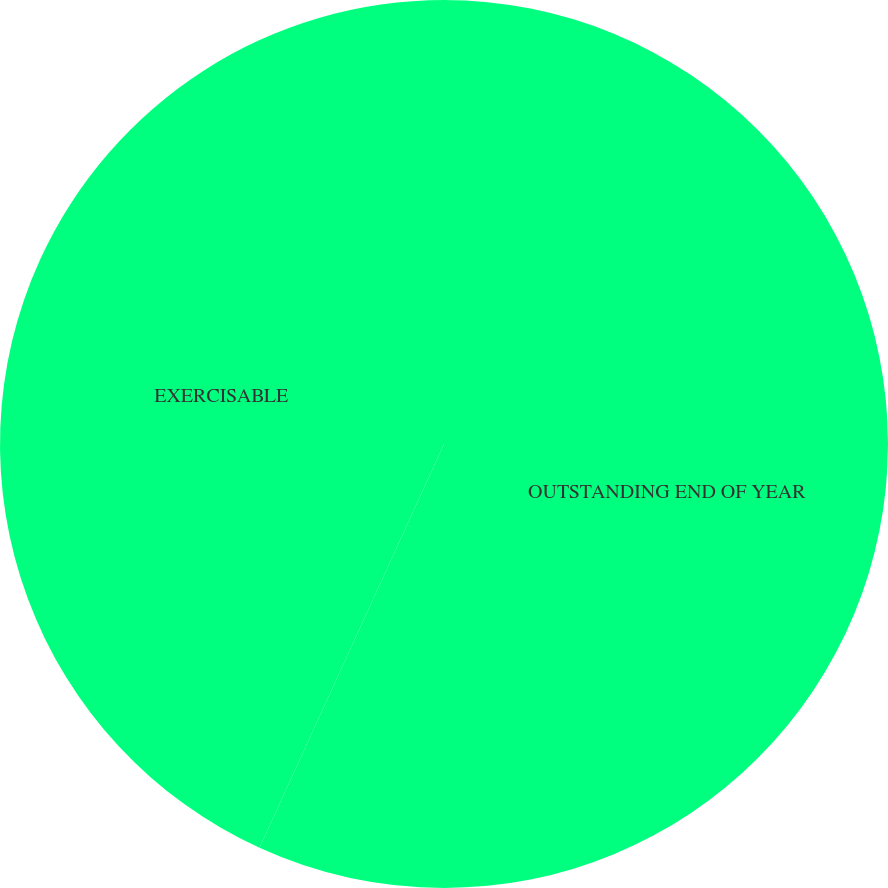Convert chart to OTSL. <chart><loc_0><loc_0><loc_500><loc_500><pie_chart><fcel>OUTSTANDING END OF YEAR<fcel>EXERCISABLE<nl><fcel>56.82%<fcel>43.18%<nl></chart> 